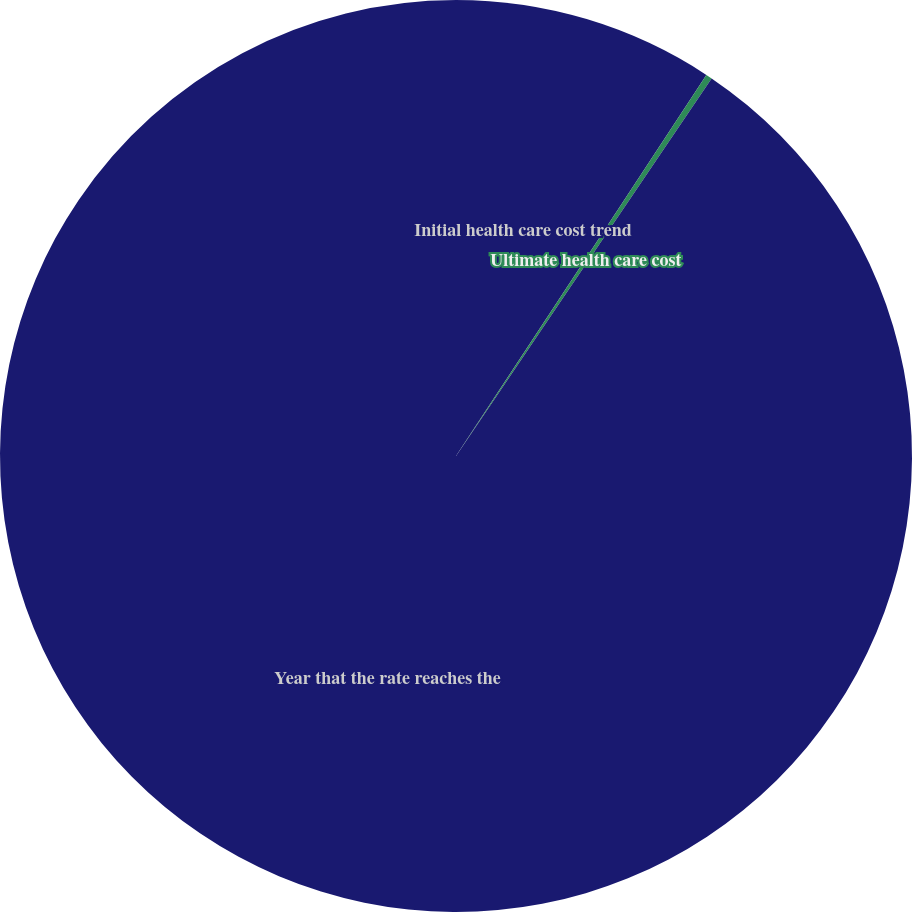Convert chart to OTSL. <chart><loc_0><loc_0><loc_500><loc_500><pie_chart><fcel>Initial health care cost trend<fcel>Ultimate health care cost<fcel>Year that the rate reaches the<nl><fcel>9.25%<fcel>0.22%<fcel>90.52%<nl></chart> 